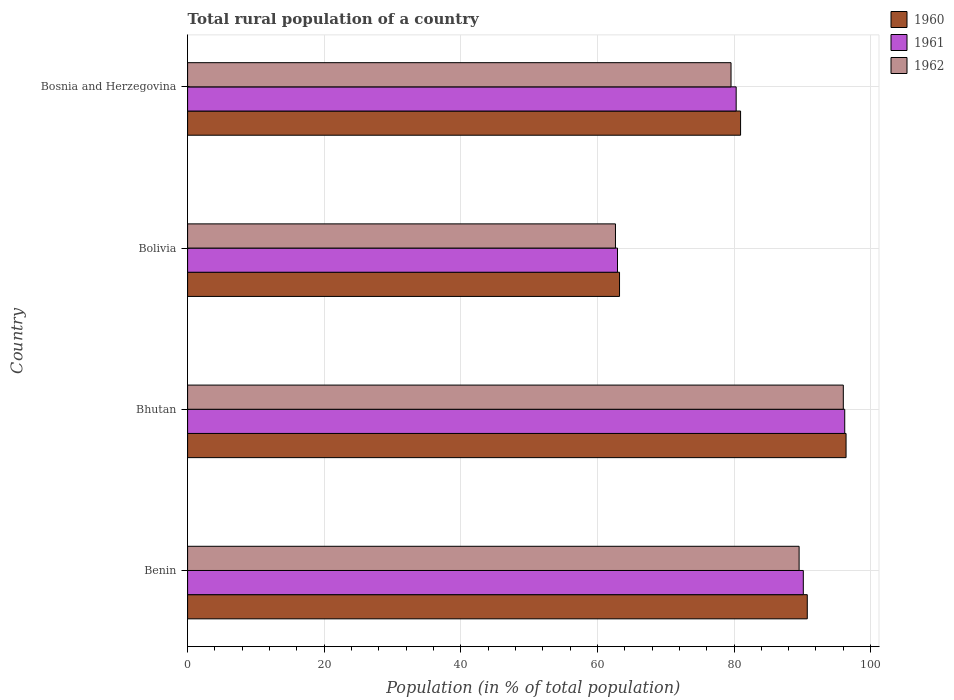How many groups of bars are there?
Your answer should be very brief. 4. How many bars are there on the 2nd tick from the bottom?
Your answer should be very brief. 3. What is the label of the 4th group of bars from the top?
Your answer should be compact. Benin. What is the rural population in 1962 in Bolivia?
Provide a short and direct response. 62.64. Across all countries, what is the maximum rural population in 1961?
Make the answer very short. 96.21. Across all countries, what is the minimum rural population in 1962?
Give a very brief answer. 62.64. In which country was the rural population in 1961 maximum?
Ensure brevity in your answer.  Bhutan. What is the total rural population in 1962 in the graph?
Your answer should be very brief. 327.74. What is the difference between the rural population in 1962 in Benin and that in Bolivia?
Your answer should be very brief. 26.89. What is the difference between the rural population in 1961 in Bhutan and the rural population in 1962 in Bosnia and Herzegovina?
Your response must be concise. 16.64. What is the average rural population in 1960 per country?
Your answer should be very brief. 82.83. What is the difference between the rural population in 1960 and rural population in 1962 in Bhutan?
Offer a terse response. 0.4. In how many countries, is the rural population in 1961 greater than 24 %?
Your answer should be very brief. 4. What is the ratio of the rural population in 1961 in Bhutan to that in Bosnia and Herzegovina?
Keep it short and to the point. 1.2. Is the difference between the rural population in 1960 in Bhutan and Bosnia and Herzegovina greater than the difference between the rural population in 1962 in Bhutan and Bosnia and Herzegovina?
Ensure brevity in your answer.  No. What is the difference between the highest and the second highest rural population in 1962?
Provide a short and direct response. 6.47. What is the difference between the highest and the lowest rural population in 1962?
Make the answer very short. 33.36. What does the 3rd bar from the top in Bosnia and Herzegovina represents?
Offer a terse response. 1960. What does the 2nd bar from the bottom in Bolivia represents?
Ensure brevity in your answer.  1961. Is it the case that in every country, the sum of the rural population in 1960 and rural population in 1962 is greater than the rural population in 1961?
Your response must be concise. Yes. Are all the bars in the graph horizontal?
Offer a terse response. Yes. Does the graph contain grids?
Give a very brief answer. Yes. Where does the legend appear in the graph?
Provide a succinct answer. Top right. How are the legend labels stacked?
Your answer should be very brief. Vertical. What is the title of the graph?
Offer a very short reply. Total rural population of a country. Does "2012" appear as one of the legend labels in the graph?
Make the answer very short. No. What is the label or title of the X-axis?
Make the answer very short. Population (in % of total population). What is the Population (in % of total population) in 1960 in Benin?
Keep it short and to the point. 90.72. What is the Population (in % of total population) of 1961 in Benin?
Make the answer very short. 90.14. What is the Population (in % of total population) of 1962 in Benin?
Your answer should be compact. 89.53. What is the Population (in % of total population) of 1960 in Bhutan?
Your answer should be very brief. 96.4. What is the Population (in % of total population) of 1961 in Bhutan?
Offer a terse response. 96.21. What is the Population (in % of total population) in 1962 in Bhutan?
Offer a very short reply. 96. What is the Population (in % of total population) in 1960 in Bolivia?
Ensure brevity in your answer.  63.24. What is the Population (in % of total population) of 1961 in Bolivia?
Your response must be concise. 62.94. What is the Population (in % of total population) of 1962 in Bolivia?
Offer a very short reply. 62.64. What is the Population (in % of total population) of 1960 in Bosnia and Herzegovina?
Make the answer very short. 80.96. What is the Population (in % of total population) of 1961 in Bosnia and Herzegovina?
Provide a short and direct response. 80.31. What is the Population (in % of total population) of 1962 in Bosnia and Herzegovina?
Your answer should be very brief. 79.56. Across all countries, what is the maximum Population (in % of total population) of 1960?
Provide a succinct answer. 96.4. Across all countries, what is the maximum Population (in % of total population) of 1961?
Your response must be concise. 96.21. Across all countries, what is the maximum Population (in % of total population) in 1962?
Provide a short and direct response. 96. Across all countries, what is the minimum Population (in % of total population) of 1960?
Make the answer very short. 63.24. Across all countries, what is the minimum Population (in % of total population) of 1961?
Provide a succinct answer. 62.94. Across all countries, what is the minimum Population (in % of total population) of 1962?
Make the answer very short. 62.64. What is the total Population (in % of total population) of 1960 in the graph?
Your answer should be very brief. 331.33. What is the total Population (in % of total population) of 1961 in the graph?
Offer a terse response. 329.61. What is the total Population (in % of total population) of 1962 in the graph?
Give a very brief answer. 327.74. What is the difference between the Population (in % of total population) in 1960 in Benin and that in Bhutan?
Provide a short and direct response. -5.68. What is the difference between the Population (in % of total population) in 1961 in Benin and that in Bhutan?
Ensure brevity in your answer.  -6.06. What is the difference between the Population (in % of total population) in 1962 in Benin and that in Bhutan?
Your answer should be compact. -6.47. What is the difference between the Population (in % of total population) in 1960 in Benin and that in Bolivia?
Offer a terse response. 27.49. What is the difference between the Population (in % of total population) of 1961 in Benin and that in Bolivia?
Ensure brevity in your answer.  27.2. What is the difference between the Population (in % of total population) in 1962 in Benin and that in Bolivia?
Provide a short and direct response. 26.89. What is the difference between the Population (in % of total population) of 1960 in Benin and that in Bosnia and Herzegovina?
Provide a succinct answer. 9.77. What is the difference between the Population (in % of total population) of 1961 in Benin and that in Bosnia and Herzegovina?
Make the answer very short. 9.83. What is the difference between the Population (in % of total population) in 1962 in Benin and that in Bosnia and Herzegovina?
Your answer should be very brief. 9.97. What is the difference between the Population (in % of total population) in 1960 in Bhutan and that in Bolivia?
Your response must be concise. 33.17. What is the difference between the Population (in % of total population) of 1961 in Bhutan and that in Bolivia?
Ensure brevity in your answer.  33.27. What is the difference between the Population (in % of total population) of 1962 in Bhutan and that in Bolivia?
Provide a short and direct response. 33.36. What is the difference between the Population (in % of total population) of 1960 in Bhutan and that in Bosnia and Herzegovina?
Make the answer very short. 15.44. What is the difference between the Population (in % of total population) of 1961 in Bhutan and that in Bosnia and Herzegovina?
Give a very brief answer. 15.89. What is the difference between the Population (in % of total population) of 1962 in Bhutan and that in Bosnia and Herzegovina?
Provide a succinct answer. 16.44. What is the difference between the Population (in % of total population) in 1960 in Bolivia and that in Bosnia and Herzegovina?
Offer a very short reply. -17.72. What is the difference between the Population (in % of total population) in 1961 in Bolivia and that in Bosnia and Herzegovina?
Provide a succinct answer. -17.37. What is the difference between the Population (in % of total population) of 1962 in Bolivia and that in Bosnia and Herzegovina?
Offer a very short reply. -16.92. What is the difference between the Population (in % of total population) of 1960 in Benin and the Population (in % of total population) of 1961 in Bhutan?
Provide a succinct answer. -5.48. What is the difference between the Population (in % of total population) in 1960 in Benin and the Population (in % of total population) in 1962 in Bhutan?
Keep it short and to the point. -5.28. What is the difference between the Population (in % of total population) in 1961 in Benin and the Population (in % of total population) in 1962 in Bhutan?
Make the answer very short. -5.86. What is the difference between the Population (in % of total population) in 1960 in Benin and the Population (in % of total population) in 1961 in Bolivia?
Offer a very short reply. 27.78. What is the difference between the Population (in % of total population) in 1960 in Benin and the Population (in % of total population) in 1962 in Bolivia?
Make the answer very short. 28.08. What is the difference between the Population (in % of total population) of 1961 in Benin and the Population (in % of total population) of 1962 in Bolivia?
Provide a succinct answer. 27.5. What is the difference between the Population (in % of total population) of 1960 in Benin and the Population (in % of total population) of 1961 in Bosnia and Herzegovina?
Ensure brevity in your answer.  10.41. What is the difference between the Population (in % of total population) of 1960 in Benin and the Population (in % of total population) of 1962 in Bosnia and Herzegovina?
Offer a very short reply. 11.16. What is the difference between the Population (in % of total population) in 1961 in Benin and the Population (in % of total population) in 1962 in Bosnia and Herzegovina?
Offer a very short reply. 10.58. What is the difference between the Population (in % of total population) in 1960 in Bhutan and the Population (in % of total population) in 1961 in Bolivia?
Make the answer very short. 33.46. What is the difference between the Population (in % of total population) of 1960 in Bhutan and the Population (in % of total population) of 1962 in Bolivia?
Give a very brief answer. 33.76. What is the difference between the Population (in % of total population) in 1961 in Bhutan and the Population (in % of total population) in 1962 in Bolivia?
Provide a short and direct response. 33.56. What is the difference between the Population (in % of total population) of 1960 in Bhutan and the Population (in % of total population) of 1961 in Bosnia and Herzegovina?
Offer a very short reply. 16.09. What is the difference between the Population (in % of total population) of 1960 in Bhutan and the Population (in % of total population) of 1962 in Bosnia and Herzegovina?
Give a very brief answer. 16.84. What is the difference between the Population (in % of total population) of 1961 in Bhutan and the Population (in % of total population) of 1962 in Bosnia and Herzegovina?
Your answer should be compact. 16.64. What is the difference between the Population (in % of total population) of 1960 in Bolivia and the Population (in % of total population) of 1961 in Bosnia and Herzegovina?
Give a very brief answer. -17.08. What is the difference between the Population (in % of total population) of 1960 in Bolivia and the Population (in % of total population) of 1962 in Bosnia and Herzegovina?
Make the answer very short. -16.32. What is the difference between the Population (in % of total population) of 1961 in Bolivia and the Population (in % of total population) of 1962 in Bosnia and Herzegovina?
Make the answer very short. -16.62. What is the average Population (in % of total population) in 1960 per country?
Ensure brevity in your answer.  82.83. What is the average Population (in % of total population) of 1961 per country?
Offer a very short reply. 82.4. What is the average Population (in % of total population) of 1962 per country?
Your answer should be very brief. 81.93. What is the difference between the Population (in % of total population) of 1960 and Population (in % of total population) of 1961 in Benin?
Provide a succinct answer. 0.58. What is the difference between the Population (in % of total population) of 1960 and Population (in % of total population) of 1962 in Benin?
Your answer should be compact. 1.2. What is the difference between the Population (in % of total population) of 1961 and Population (in % of total population) of 1962 in Benin?
Make the answer very short. 0.61. What is the difference between the Population (in % of total population) of 1960 and Population (in % of total population) of 1961 in Bhutan?
Your answer should be very brief. 0.2. What is the difference between the Population (in % of total population) of 1960 and Population (in % of total population) of 1962 in Bhutan?
Provide a succinct answer. 0.4. What is the difference between the Population (in % of total population) of 1961 and Population (in % of total population) of 1962 in Bhutan?
Offer a terse response. 0.21. What is the difference between the Population (in % of total population) in 1960 and Population (in % of total population) in 1961 in Bolivia?
Your answer should be very brief. 0.3. What is the difference between the Population (in % of total population) in 1960 and Population (in % of total population) in 1962 in Bolivia?
Your answer should be compact. 0.59. What is the difference between the Population (in % of total population) of 1961 and Population (in % of total population) of 1962 in Bolivia?
Your response must be concise. 0.3. What is the difference between the Population (in % of total population) in 1960 and Population (in % of total population) in 1961 in Bosnia and Herzegovina?
Your answer should be compact. 0.65. What is the difference between the Population (in % of total population) in 1960 and Population (in % of total population) in 1962 in Bosnia and Herzegovina?
Give a very brief answer. 1.4. What is the difference between the Population (in % of total population) of 1961 and Population (in % of total population) of 1962 in Bosnia and Herzegovina?
Your response must be concise. 0.75. What is the ratio of the Population (in % of total population) in 1960 in Benin to that in Bhutan?
Keep it short and to the point. 0.94. What is the ratio of the Population (in % of total population) in 1961 in Benin to that in Bhutan?
Ensure brevity in your answer.  0.94. What is the ratio of the Population (in % of total population) of 1962 in Benin to that in Bhutan?
Give a very brief answer. 0.93. What is the ratio of the Population (in % of total population) of 1960 in Benin to that in Bolivia?
Offer a very short reply. 1.43. What is the ratio of the Population (in % of total population) in 1961 in Benin to that in Bolivia?
Provide a short and direct response. 1.43. What is the ratio of the Population (in % of total population) in 1962 in Benin to that in Bolivia?
Provide a short and direct response. 1.43. What is the ratio of the Population (in % of total population) of 1960 in Benin to that in Bosnia and Herzegovina?
Offer a terse response. 1.12. What is the ratio of the Population (in % of total population) in 1961 in Benin to that in Bosnia and Herzegovina?
Provide a succinct answer. 1.12. What is the ratio of the Population (in % of total population) in 1962 in Benin to that in Bosnia and Herzegovina?
Your answer should be very brief. 1.13. What is the ratio of the Population (in % of total population) in 1960 in Bhutan to that in Bolivia?
Your response must be concise. 1.52. What is the ratio of the Population (in % of total population) in 1961 in Bhutan to that in Bolivia?
Offer a very short reply. 1.53. What is the ratio of the Population (in % of total population) in 1962 in Bhutan to that in Bolivia?
Make the answer very short. 1.53. What is the ratio of the Population (in % of total population) in 1960 in Bhutan to that in Bosnia and Herzegovina?
Your answer should be very brief. 1.19. What is the ratio of the Population (in % of total population) of 1961 in Bhutan to that in Bosnia and Herzegovina?
Provide a succinct answer. 1.2. What is the ratio of the Population (in % of total population) of 1962 in Bhutan to that in Bosnia and Herzegovina?
Offer a very short reply. 1.21. What is the ratio of the Population (in % of total population) of 1960 in Bolivia to that in Bosnia and Herzegovina?
Make the answer very short. 0.78. What is the ratio of the Population (in % of total population) of 1961 in Bolivia to that in Bosnia and Herzegovina?
Your answer should be compact. 0.78. What is the ratio of the Population (in % of total population) of 1962 in Bolivia to that in Bosnia and Herzegovina?
Provide a short and direct response. 0.79. What is the difference between the highest and the second highest Population (in % of total population) of 1960?
Make the answer very short. 5.68. What is the difference between the highest and the second highest Population (in % of total population) in 1961?
Give a very brief answer. 6.06. What is the difference between the highest and the second highest Population (in % of total population) in 1962?
Offer a terse response. 6.47. What is the difference between the highest and the lowest Population (in % of total population) in 1960?
Make the answer very short. 33.17. What is the difference between the highest and the lowest Population (in % of total population) of 1961?
Your response must be concise. 33.27. What is the difference between the highest and the lowest Population (in % of total population) in 1962?
Give a very brief answer. 33.36. 